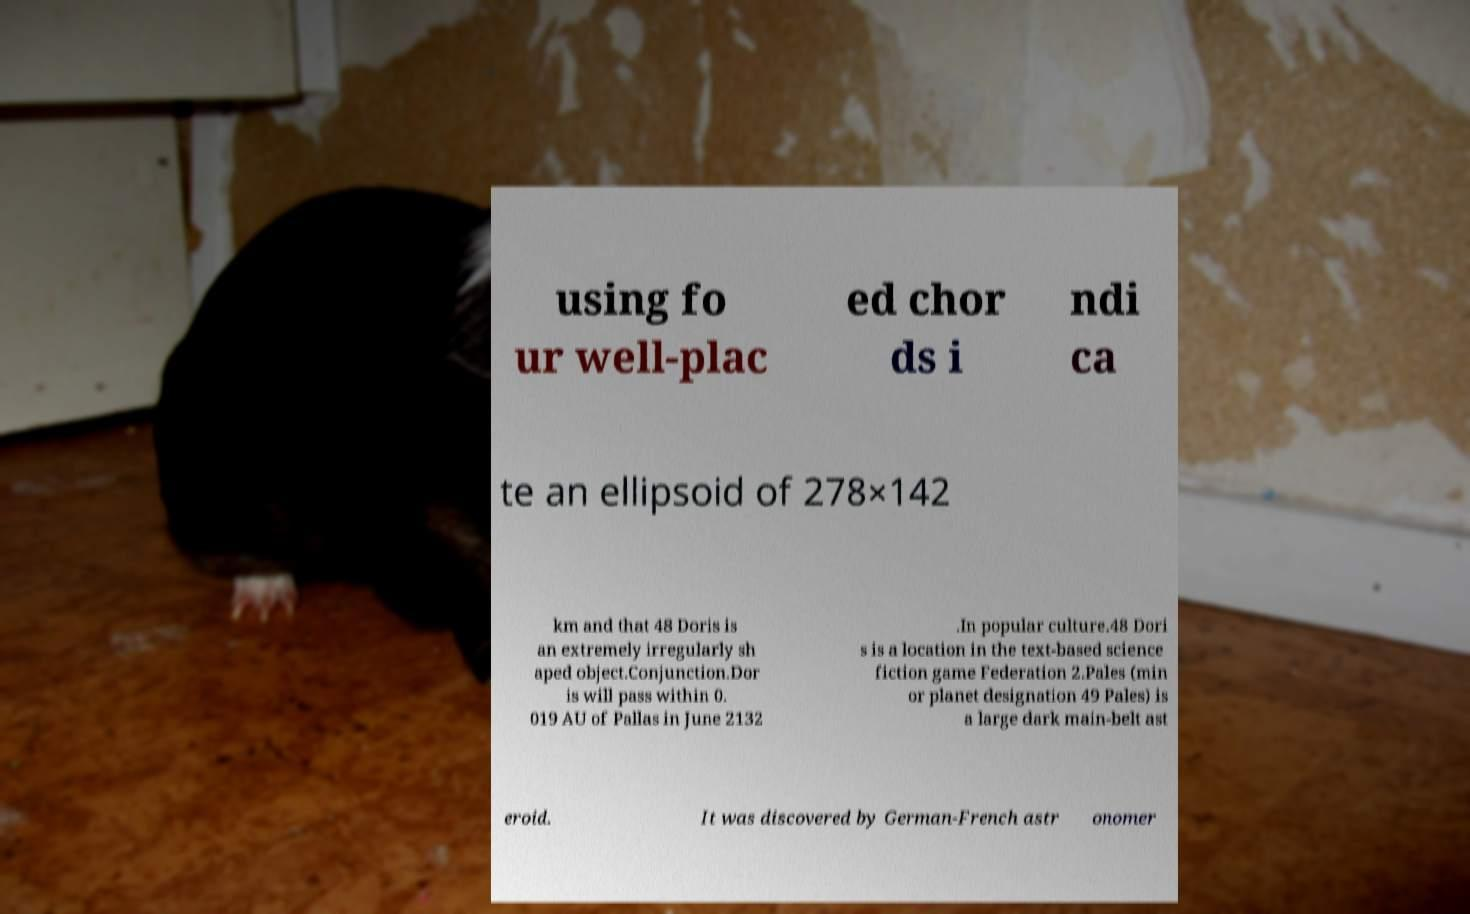Could you assist in decoding the text presented in this image and type it out clearly? using fo ur well-plac ed chor ds i ndi ca te an ellipsoid of 278×142 km and that 48 Doris is an extremely irregularly sh aped object.Conjunction.Dor is will pass within 0. 019 AU of Pallas in June 2132 .In popular culture.48 Dori s is a location in the text-based science fiction game Federation 2.Pales (min or planet designation 49 Pales) is a large dark main-belt ast eroid. It was discovered by German-French astr onomer 